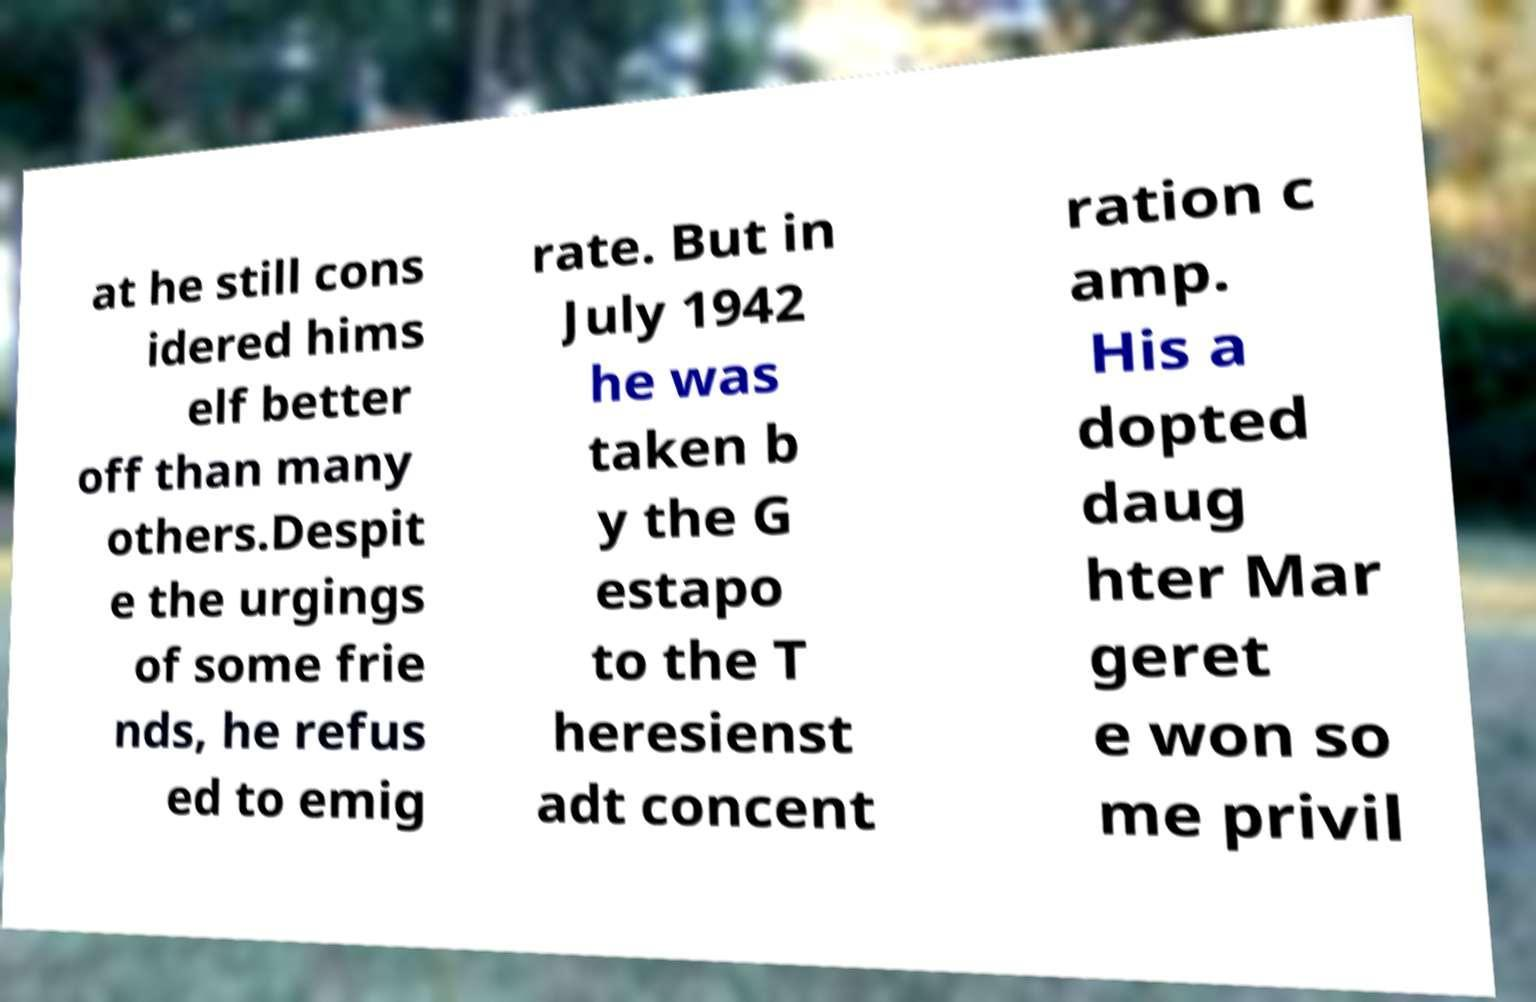I need the written content from this picture converted into text. Can you do that? at he still cons idered hims elf better off than many others.Despit e the urgings of some frie nds, he refus ed to emig rate. But in July 1942 he was taken b y the G estapo to the T heresienst adt concent ration c amp. His a dopted daug hter Mar geret e won so me privil 